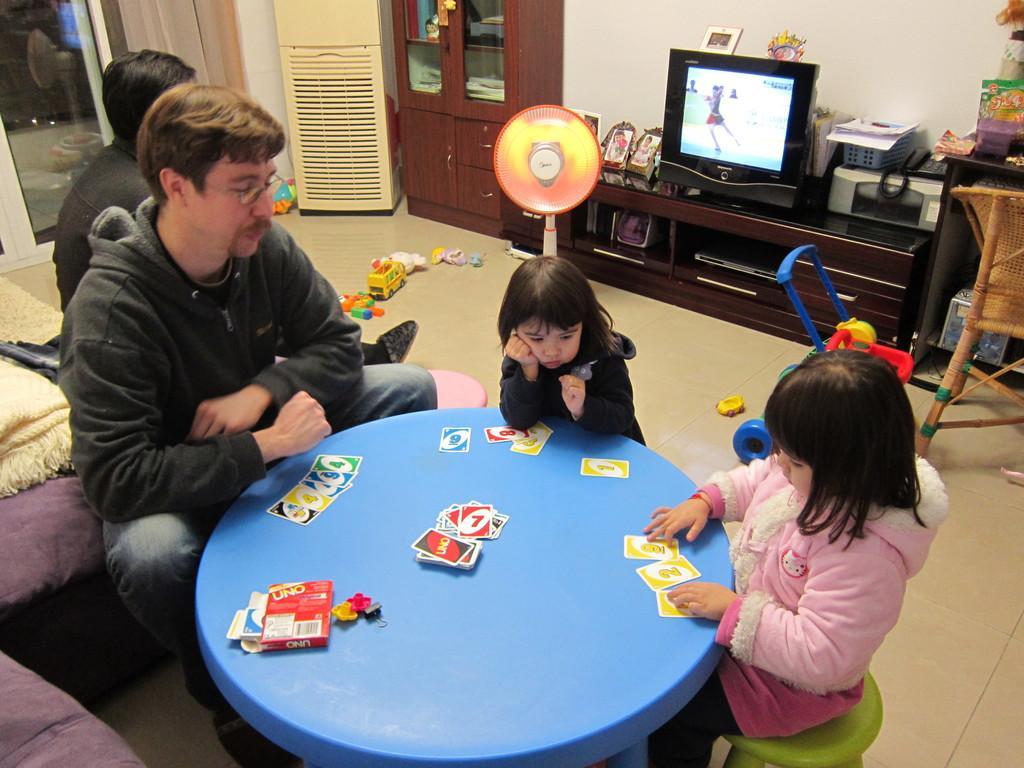In one or two sentences, can you explain what this image depicts? In this image I can see two girls sitting on the chairs and a man wearing the jacket sitting on the couch around the table, on the table i can see few uno cards and a card box. In the background i can see a fan, few toys on the floor,a chair, a desk on which there is a television screen,few photo frames, a telephone,a printer and few other objects. I can see the wall,a cabinet, air cooler, a person sitting on the couch and the door. 